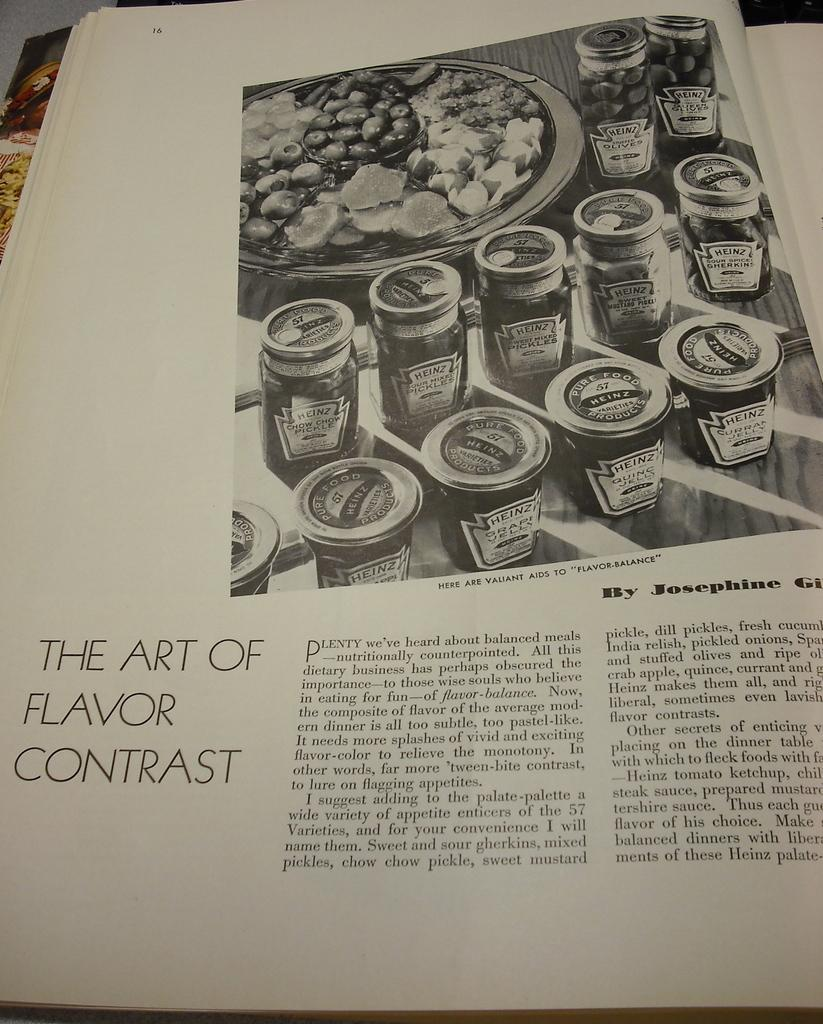<image>
Present a compact description of the photo's key features. A book page that states the art of flavor contrast 